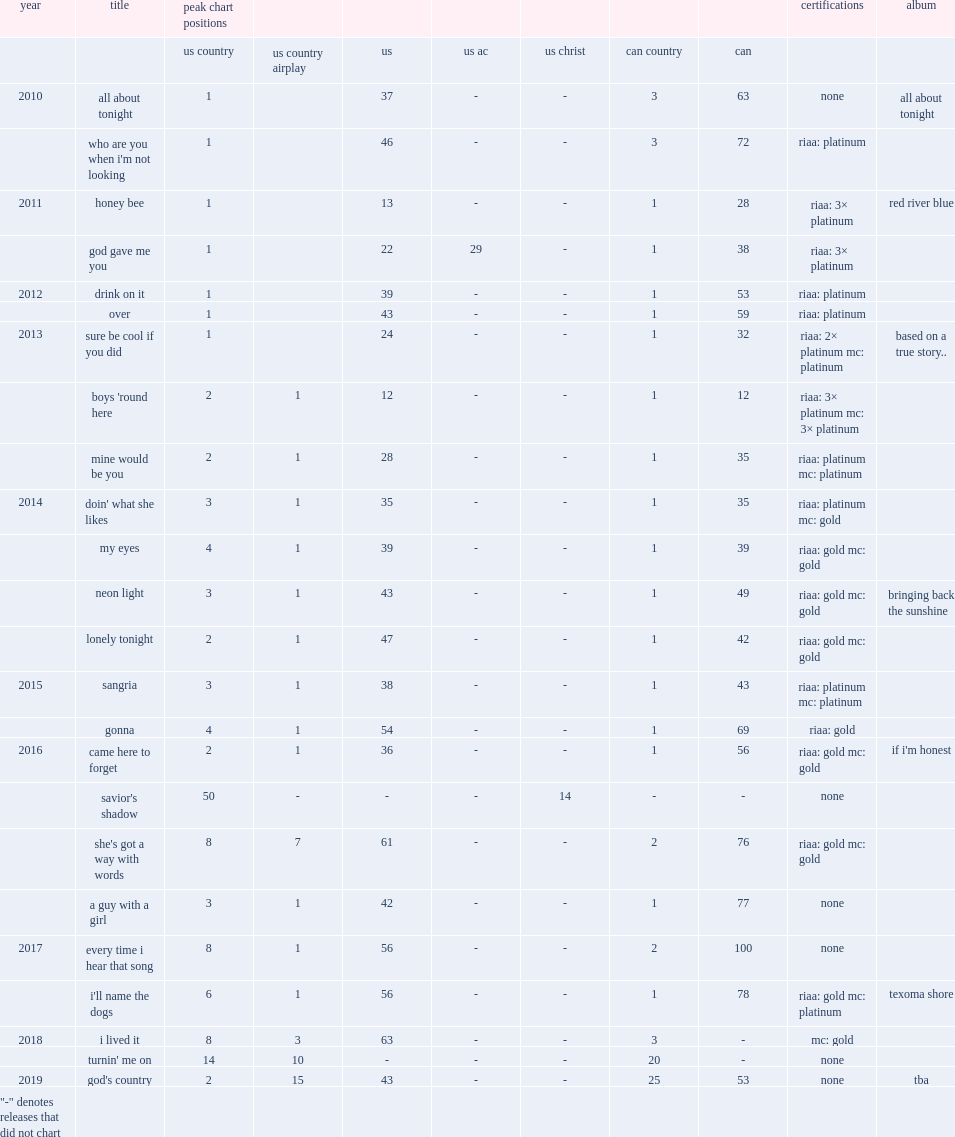Which album of blake shelton contains four number 1 singles including "honey bee", "god gave me you", "drink on it" and "over"? Red river blue. 